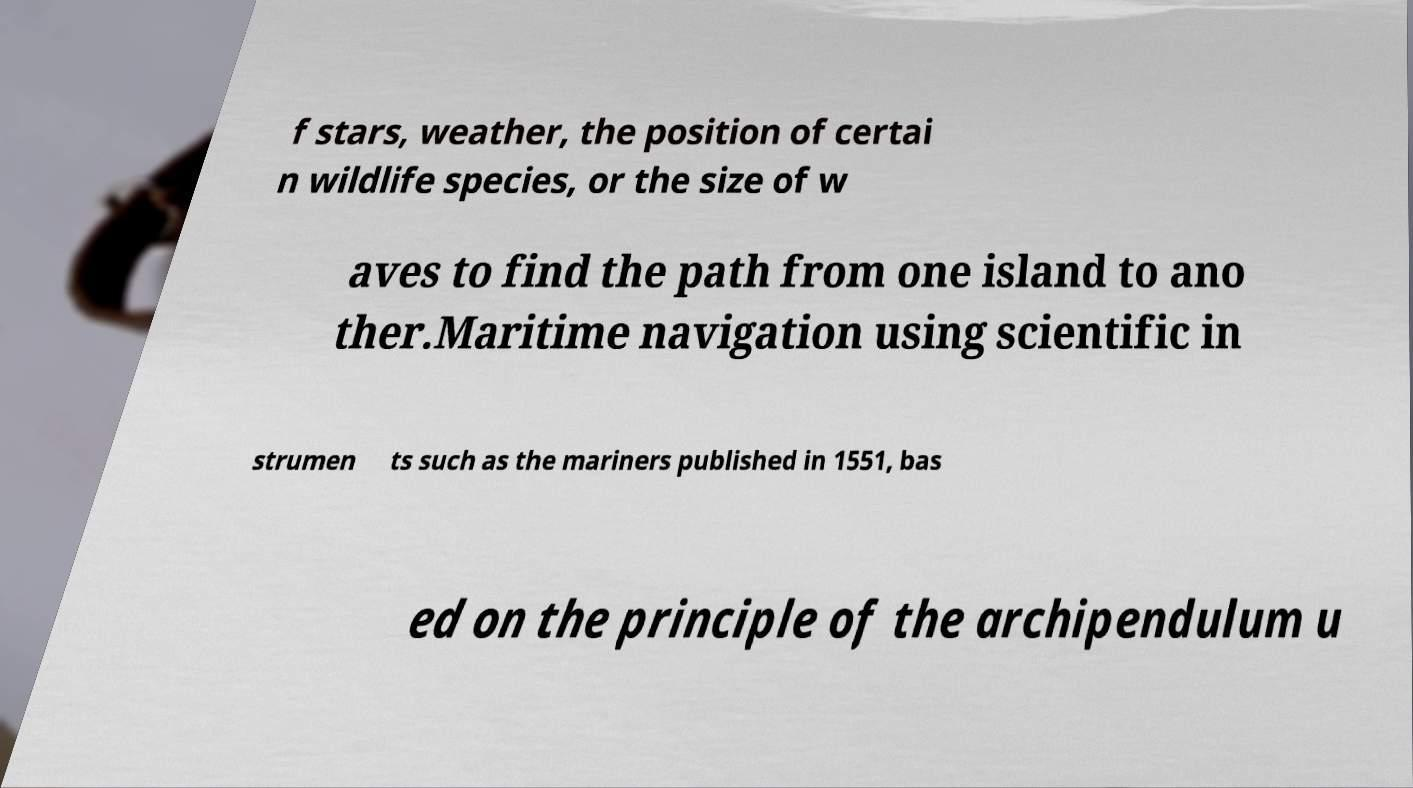For documentation purposes, I need the text within this image transcribed. Could you provide that? f stars, weather, the position of certai n wildlife species, or the size of w aves to find the path from one island to ano ther.Maritime navigation using scientific in strumen ts such as the mariners published in 1551, bas ed on the principle of the archipendulum u 